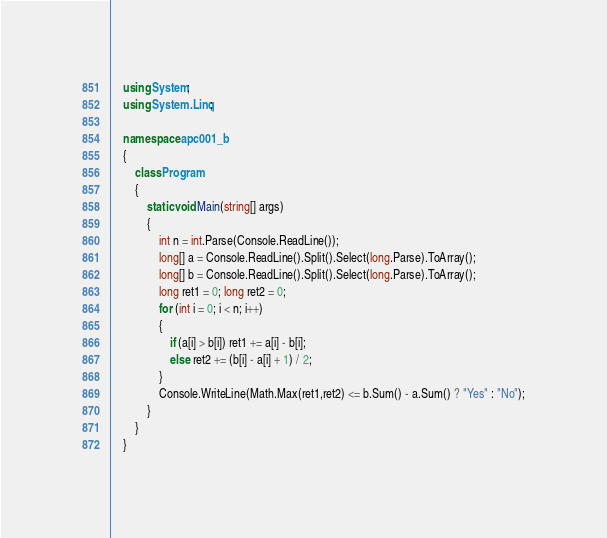<code> <loc_0><loc_0><loc_500><loc_500><_C#_>    using System;
    using System.Linq;
     
    namespace apc001_b
    {
        class Program
        {
            static void Main(string[] args)
            {
                int n = int.Parse(Console.ReadLine());
                long[] a = Console.ReadLine().Split().Select(long.Parse).ToArray();
                long[] b = Console.ReadLine().Split().Select(long.Parse).ToArray();
                long ret1 = 0; long ret2 = 0;
                for (int i = 0; i < n; i++)
                {
                    if (a[i] > b[i]) ret1 += a[i] - b[i];
                    else ret2 += (b[i] - a[i] + 1) / 2;
                }
                Console.WriteLine(Math.Max(ret1,ret2) <= b.Sum() - a.Sum() ? "Yes" : "No");
            }
        }
    }</code> 